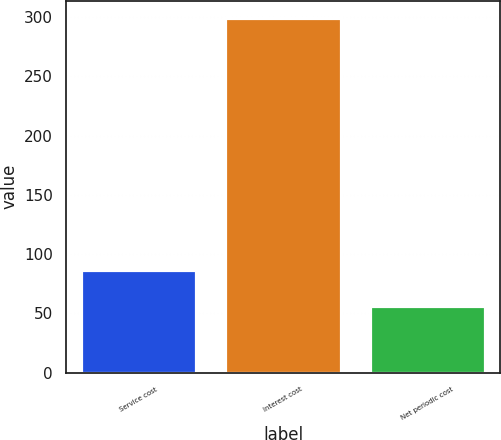Convert chart. <chart><loc_0><loc_0><loc_500><loc_500><bar_chart><fcel>Service cost<fcel>Interest cost<fcel>Net periodic cost<nl><fcel>87<fcel>299<fcel>56<nl></chart> 